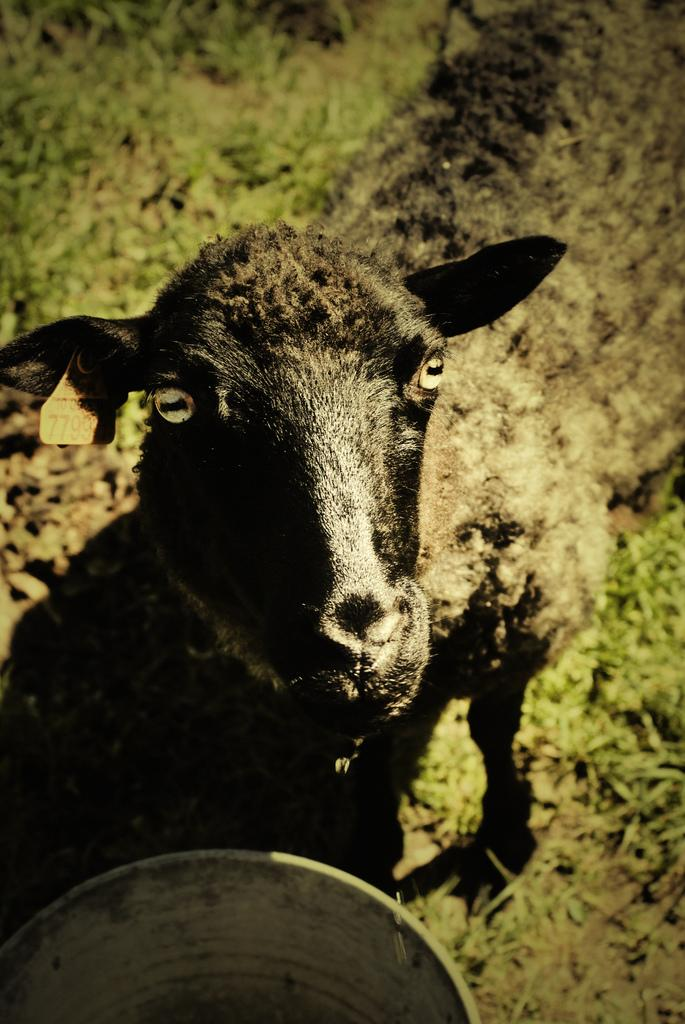What type of animal is in the image? There is a goat in the image. What object is also present in the image? There is a bucket in the image. What type of vegetation is at the bottom of the image? There is grass at the bottom of the image. What idea does the goat have about taking a trip to space? There is no indication in the image that the goat has any ideas about space travel, as the image only shows a goat, a bucket, and grass. 